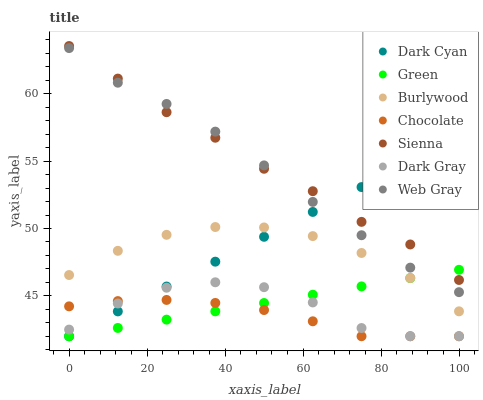Does Chocolate have the minimum area under the curve?
Answer yes or no. Yes. Does Sienna have the maximum area under the curve?
Answer yes or no. Yes. Does Web Gray have the minimum area under the curve?
Answer yes or no. No. Does Web Gray have the maximum area under the curve?
Answer yes or no. No. Is Green the smoothest?
Answer yes or no. Yes. Is Dark Gray the roughest?
Answer yes or no. Yes. Is Web Gray the smoothest?
Answer yes or no. No. Is Web Gray the roughest?
Answer yes or no. No. Does Dark Gray have the lowest value?
Answer yes or no. Yes. Does Web Gray have the lowest value?
Answer yes or no. No. Does Sienna have the highest value?
Answer yes or no. Yes. Does Web Gray have the highest value?
Answer yes or no. No. Is Burlywood less than Sienna?
Answer yes or no. Yes. Is Sienna greater than Chocolate?
Answer yes or no. Yes. Does Burlywood intersect Dark Cyan?
Answer yes or no. Yes. Is Burlywood less than Dark Cyan?
Answer yes or no. No. Is Burlywood greater than Dark Cyan?
Answer yes or no. No. Does Burlywood intersect Sienna?
Answer yes or no. No. 